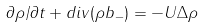<formula> <loc_0><loc_0><loc_500><loc_500>\partial \rho / \partial t + d i v ( \rho { b _ { - } } ) = - U \Delta \rho</formula> 